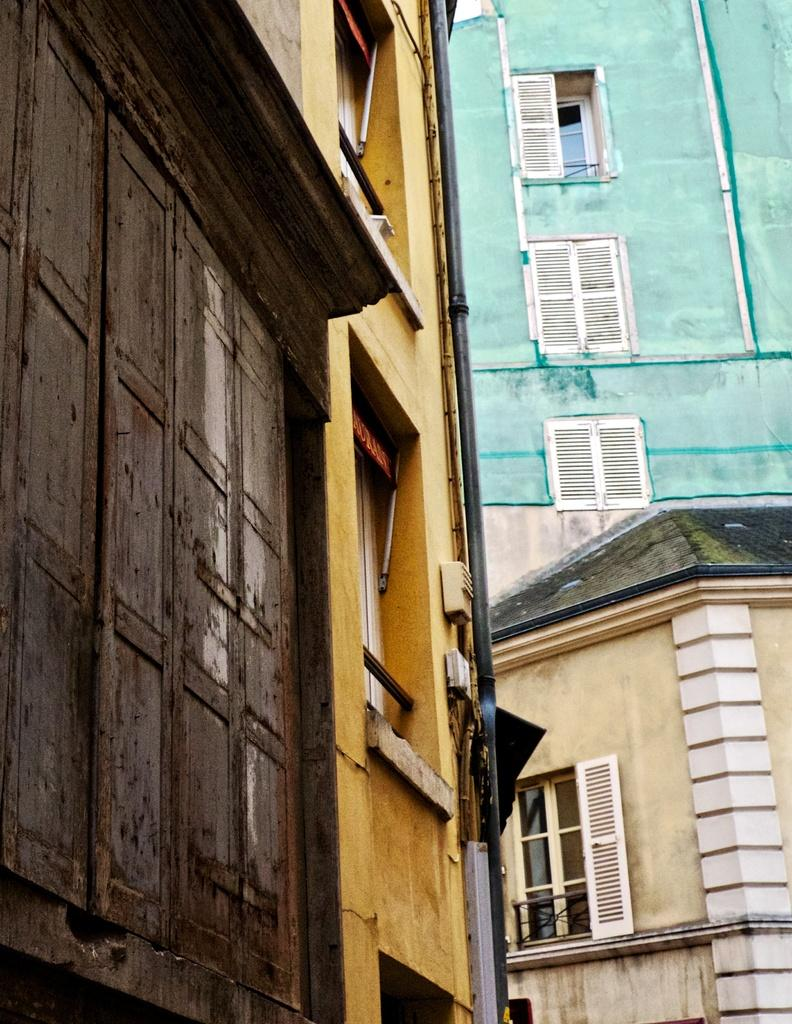What type of structure is present in the image? There is a building in the image. What part of the building is visible in the image? The windows of the building are visible in the image. What other object can be seen in the image besides the building? There is a pipe in the image. How many teeth can be seen on the building in the image? There are no teeth present on the building in the image. Is there any evidence of a crack in the building in the image? There is no mention of a crack in the building in the image. Can you spot any snails crawling on the building in the image? There is no mention of snails present on the building in the image. 